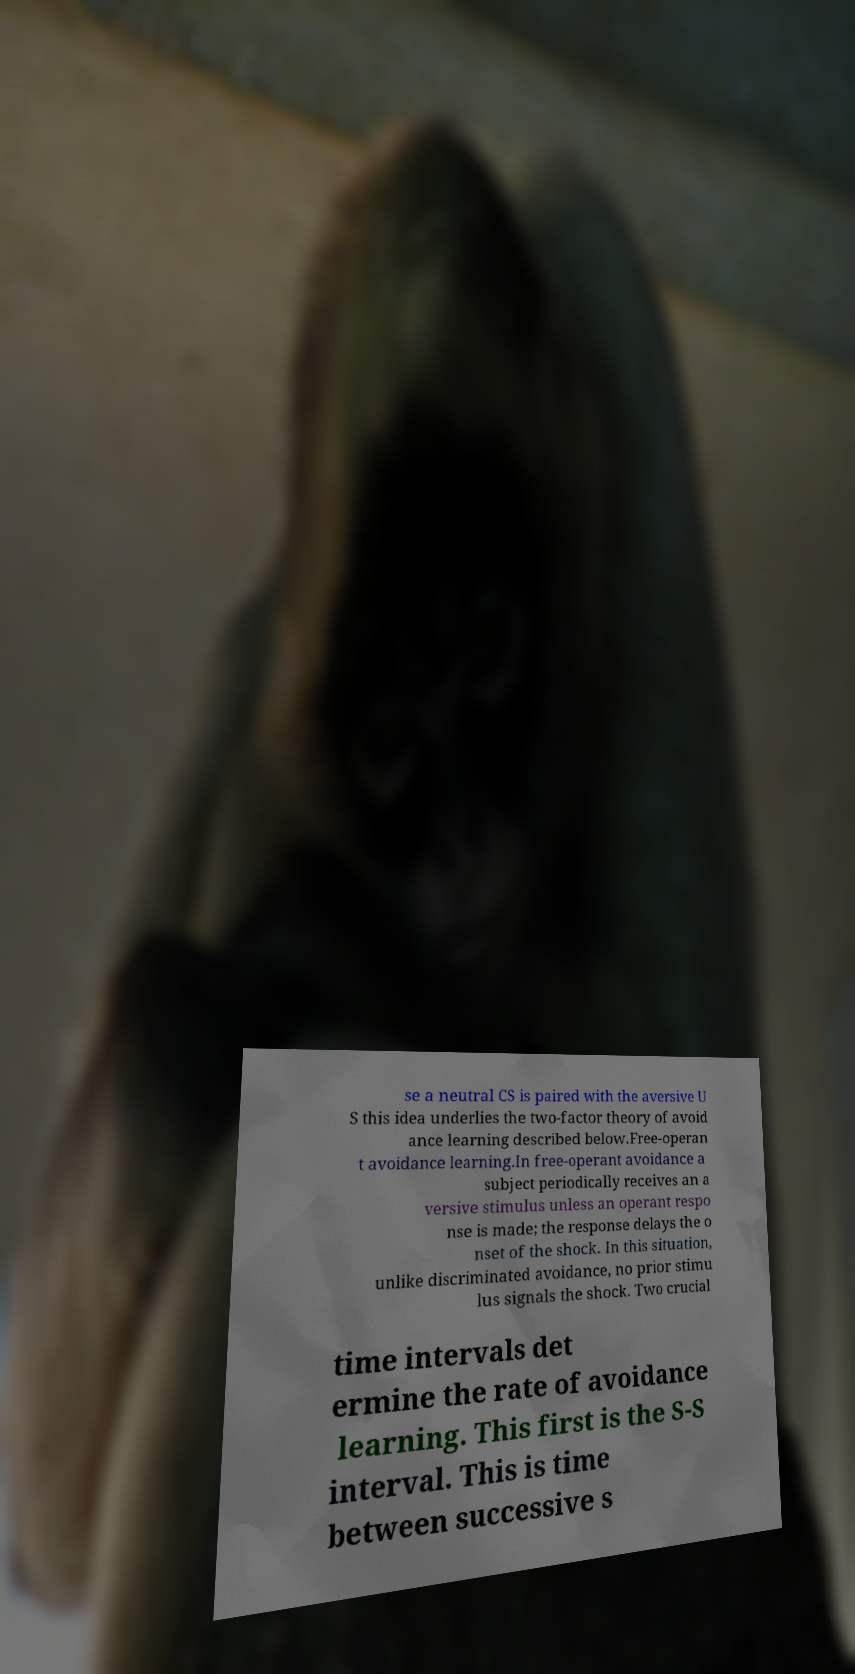There's text embedded in this image that I need extracted. Can you transcribe it verbatim? se a neutral CS is paired with the aversive U S this idea underlies the two-factor theory of avoid ance learning described below.Free-operan t avoidance learning.In free-operant avoidance a subject periodically receives an a versive stimulus unless an operant respo nse is made; the response delays the o nset of the shock. In this situation, unlike discriminated avoidance, no prior stimu lus signals the shock. Two crucial time intervals det ermine the rate of avoidance learning. This first is the S-S interval. This is time between successive s 